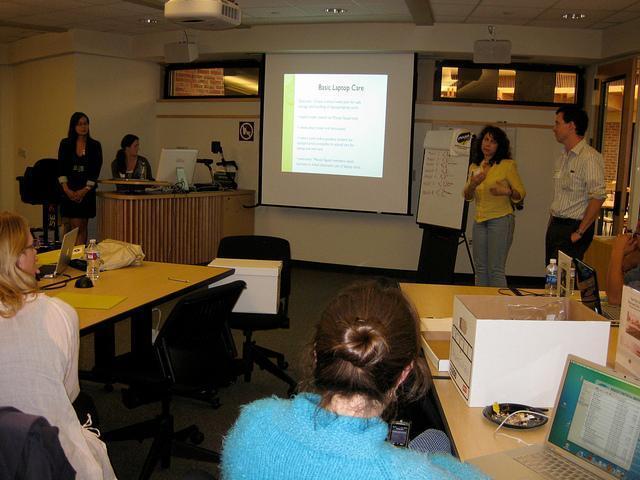How many chairs can you see?
Give a very brief answer. 3. How many dining tables are in the picture?
Give a very brief answer. 1. How many people are visible?
Give a very brief answer. 4. 